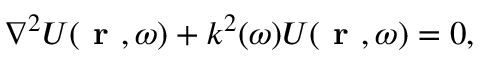<formula> <loc_0><loc_0><loc_500><loc_500>\nabla ^ { 2 } U ( r , \omega ) + k ^ { 2 } ( \omega ) U ( r , \omega ) = 0 ,</formula> 